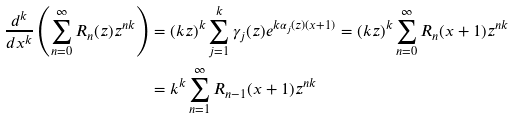<formula> <loc_0><loc_0><loc_500><loc_500>\frac { d ^ { k } } { d x ^ { k } } \left ( \sum ^ { \infty } _ { n = 0 } R _ { n } ( z ) z ^ { n k } \right ) & = ( k z ) ^ { k } \sum ^ { k } _ { j = 1 } \gamma _ { j } ( z ) e ^ { k \alpha _ { j } ( z ) ( x + 1 ) } = ( k z ) ^ { k } \sum ^ { \infty } _ { n = 0 } R _ { n } ( x + 1 ) z ^ { n k } \\ & = k ^ { k } \sum ^ { \infty } _ { n = 1 } R _ { n - 1 } ( x + 1 ) z ^ { n k }</formula> 